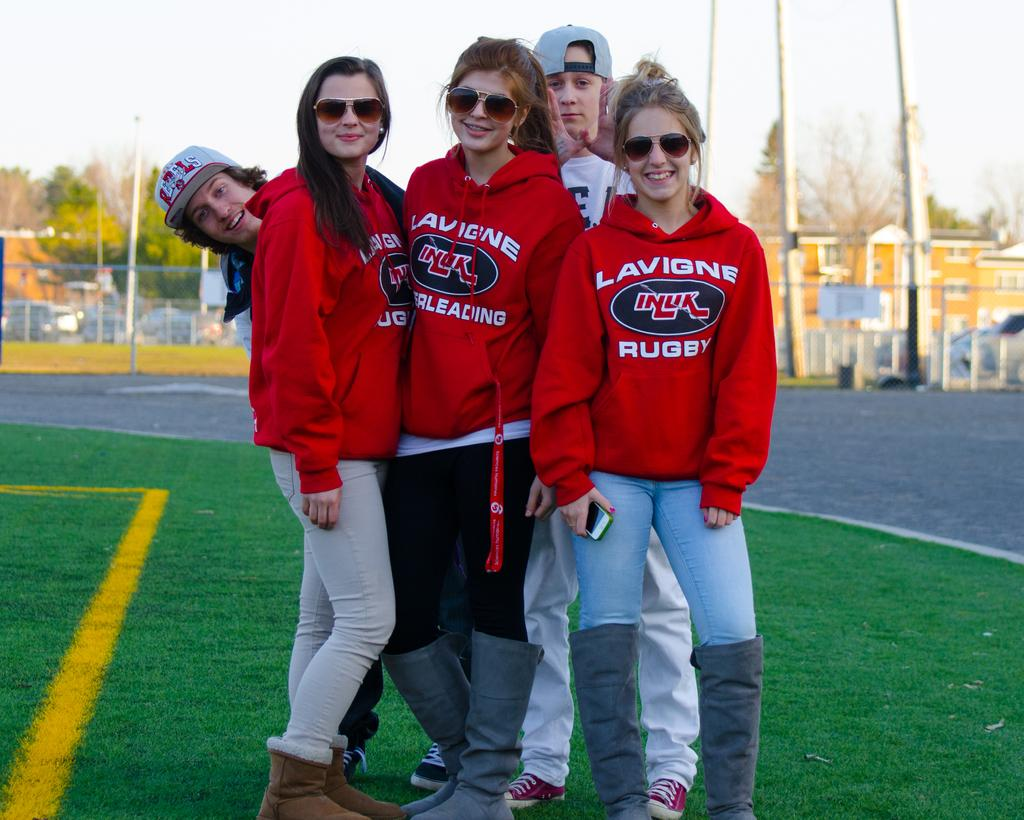<image>
Render a clear and concise summary of the photo. A group of girls wearing red hoodies with Lavigne Rugby on them. 